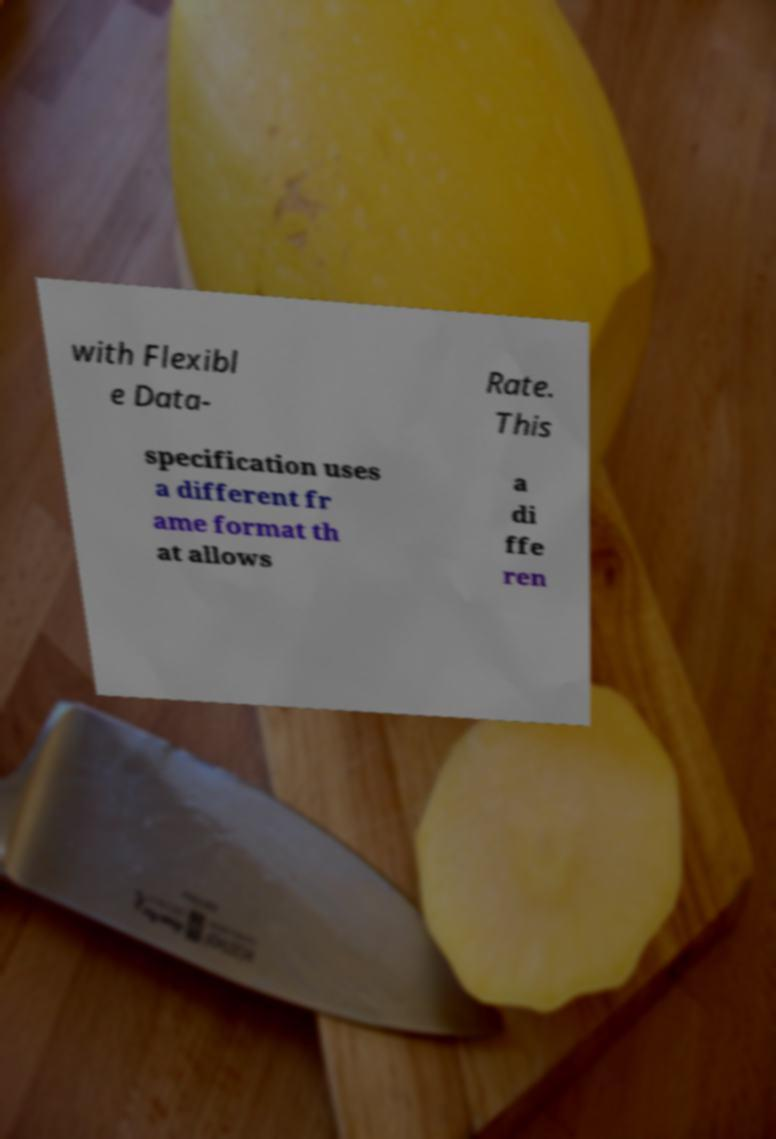Can you accurately transcribe the text from the provided image for me? with Flexibl e Data- Rate. This specification uses a different fr ame format th at allows a di ffe ren 